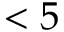Convert formula to latex. <formula><loc_0><loc_0><loc_500><loc_500>< 5</formula> 